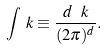Convert formula to latex. <formula><loc_0><loc_0><loc_500><loc_500>\int _ { \ } k \equiv \frac { d \ k } { ( 2 \pi ) ^ { d } } .</formula> 